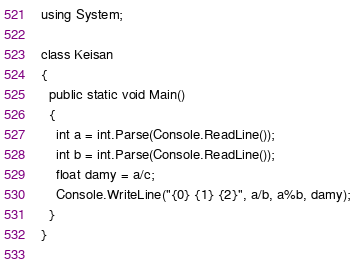<code> <loc_0><loc_0><loc_500><loc_500><_C#_>using System;

class Keisan
{
  public static void Main()
  {
    int a = int.Parse(Console.ReadLine());
    int b = int.Parse(Console.ReadLine());
    float damy = a/c;
    Console.WriteLine("{0} {1} {2}", a/b, a%b, damy);
  }
}
    </code> 